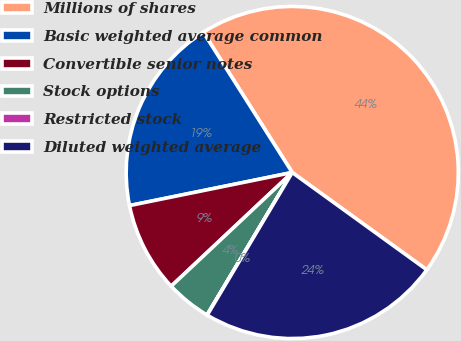Convert chart. <chart><loc_0><loc_0><loc_500><loc_500><pie_chart><fcel>Millions of shares<fcel>Basic weighted average common<fcel>Convertible senior notes<fcel>Stock options<fcel>Restricted stock<fcel>Diluted weighted average<nl><fcel>43.96%<fcel>19.2%<fcel>8.81%<fcel>4.42%<fcel>0.02%<fcel>23.59%<nl></chart> 